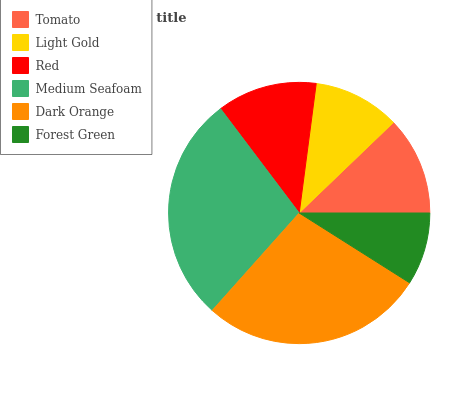Is Forest Green the minimum?
Answer yes or no. Yes. Is Medium Seafoam the maximum?
Answer yes or no. Yes. Is Light Gold the minimum?
Answer yes or no. No. Is Light Gold the maximum?
Answer yes or no. No. Is Tomato greater than Light Gold?
Answer yes or no. Yes. Is Light Gold less than Tomato?
Answer yes or no. Yes. Is Light Gold greater than Tomato?
Answer yes or no. No. Is Tomato less than Light Gold?
Answer yes or no. No. Is Red the high median?
Answer yes or no. Yes. Is Tomato the low median?
Answer yes or no. Yes. Is Dark Orange the high median?
Answer yes or no. No. Is Medium Seafoam the low median?
Answer yes or no. No. 